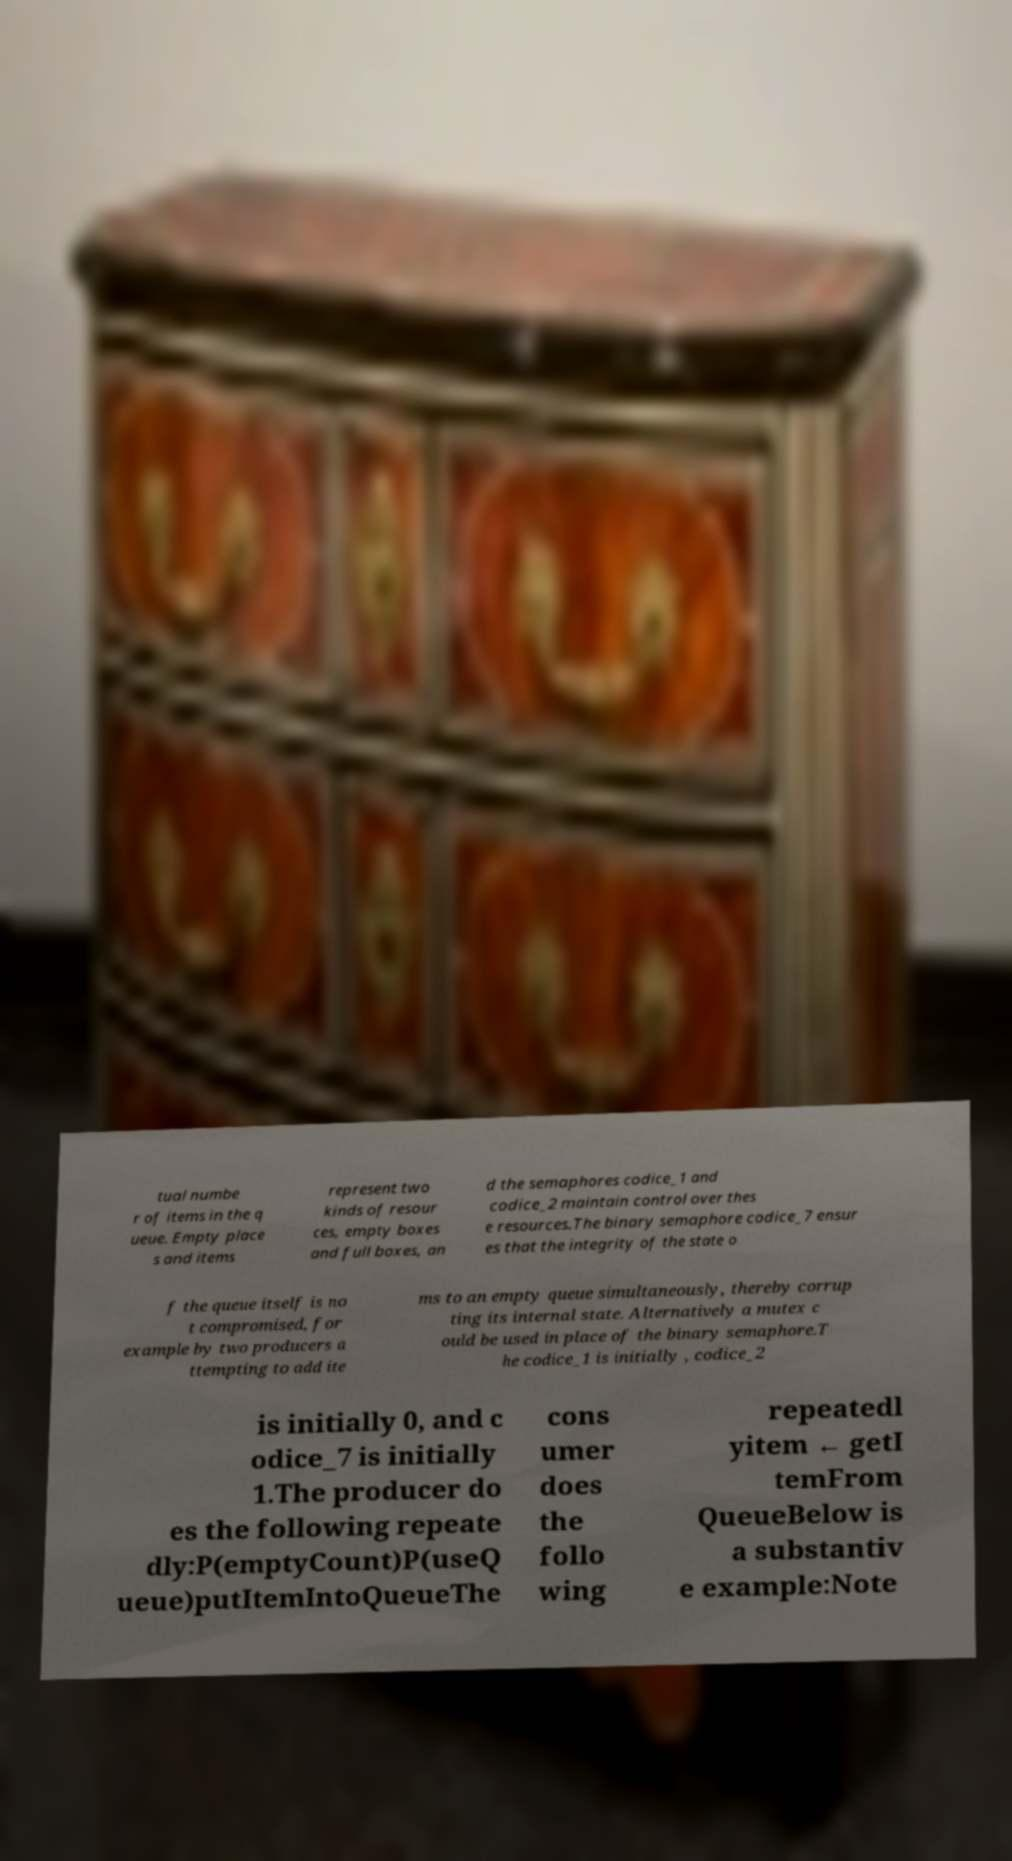Could you extract and type out the text from this image? tual numbe r of items in the q ueue. Empty place s and items represent two kinds of resour ces, empty boxes and full boxes, an d the semaphores codice_1 and codice_2 maintain control over thes e resources.The binary semaphore codice_7 ensur es that the integrity of the state o f the queue itself is no t compromised, for example by two producers a ttempting to add ite ms to an empty queue simultaneously, thereby corrup ting its internal state. Alternatively a mutex c ould be used in place of the binary semaphore.T he codice_1 is initially , codice_2 is initially 0, and c odice_7 is initially 1.The producer do es the following repeate dly:P(emptyCount)P(useQ ueue)putItemIntoQueueThe cons umer does the follo wing repeatedl yitem ← getI temFrom QueueBelow is a substantiv e example:Note 